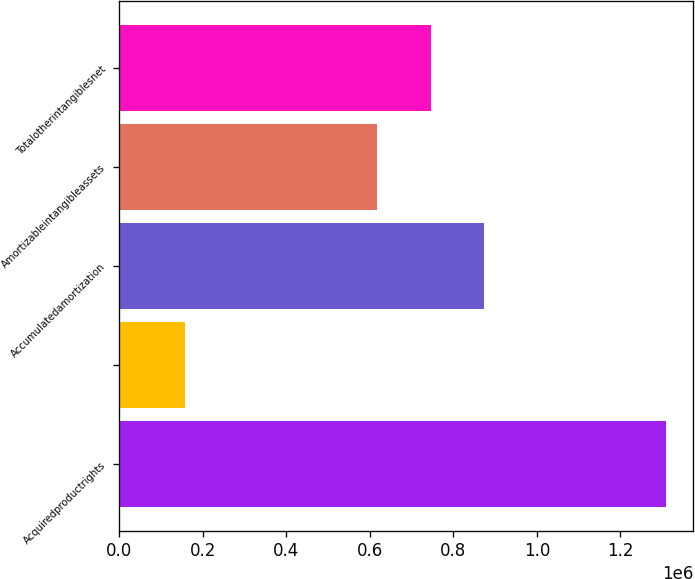Convert chart. <chart><loc_0><loc_0><loc_500><loc_500><bar_chart><fcel>Acquiredproductrights<fcel>Unnamed: 1<fcel>Accumulatedamortization<fcel>Amortizableintangibleassets<fcel>Totalotherintangiblesnet<nl><fcel>1.30934e+06<fcel>158385<fcel>873873<fcel>618104<fcel>745988<nl></chart> 